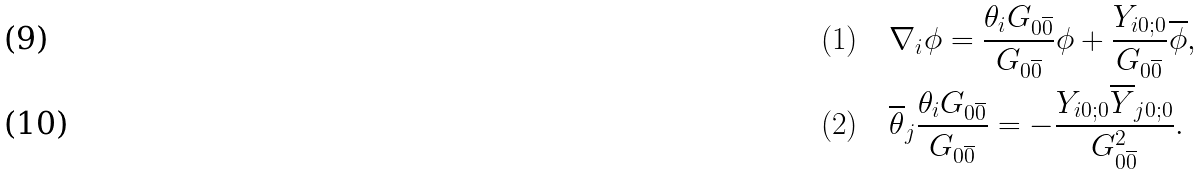Convert formula to latex. <formula><loc_0><loc_0><loc_500><loc_500>( 1 ) \quad & \nabla _ { i } \phi = \frac { \theta _ { i } G _ { 0 \overline { 0 } } } { G _ { 0 \overline { 0 } } } \phi + \frac { Y _ { i 0 ; 0 } } { G _ { 0 \overline { 0 } } } \overline { \phi } , \\ ( 2 ) \quad & \overline { \theta } _ { j } \frac { \theta _ { i } G _ { 0 \overline { 0 } } } { G _ { 0 \overline { 0 } } } = - \frac { Y _ { i 0 ; 0 } \overline { Y } _ { j 0 ; 0 } } { G _ { 0 \overline { 0 } } ^ { 2 } } .</formula> 